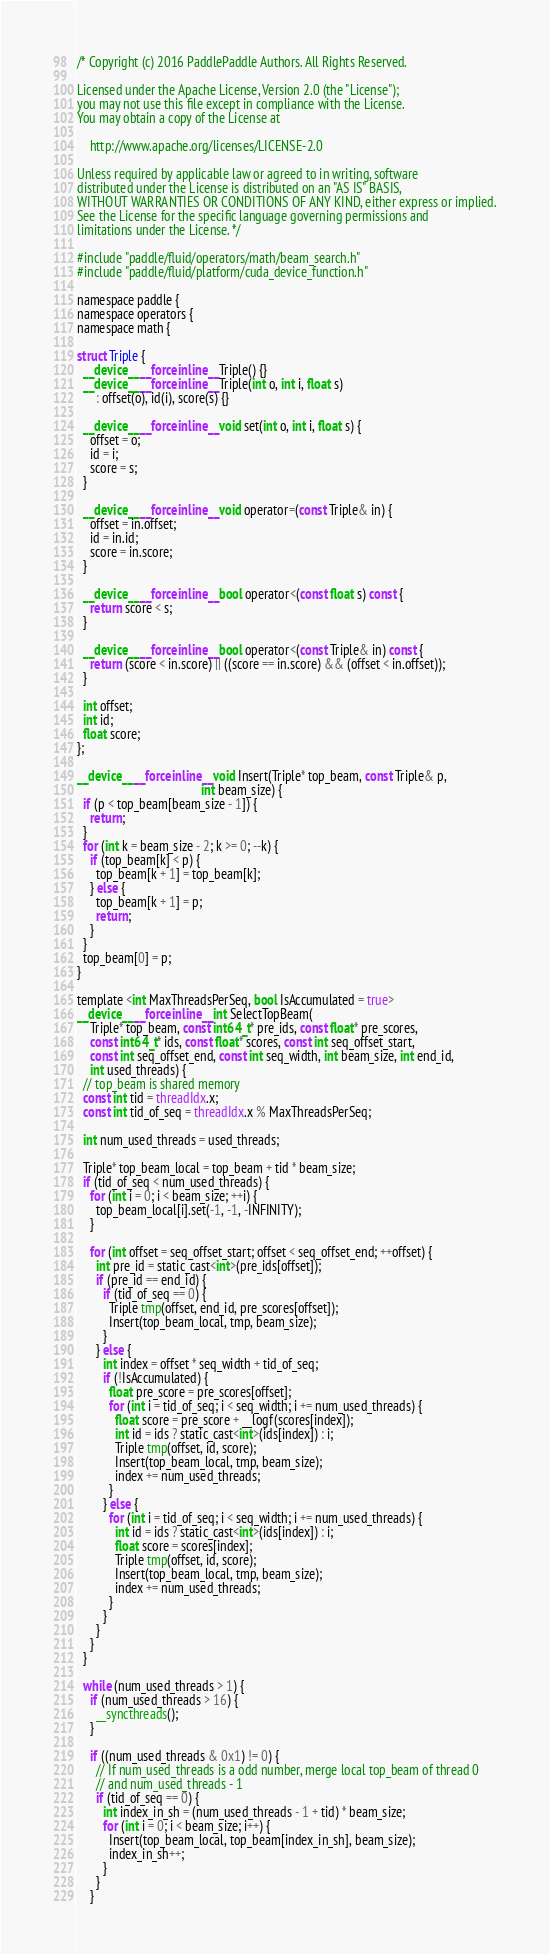<code> <loc_0><loc_0><loc_500><loc_500><_Cuda_>/* Copyright (c) 2016 PaddlePaddle Authors. All Rights Reserved.

Licensed under the Apache License, Version 2.0 (the "License");
you may not use this file except in compliance with the License.
You may obtain a copy of the License at

    http://www.apache.org/licenses/LICENSE-2.0

Unless required by applicable law or agreed to in writing, software
distributed under the License is distributed on an "AS IS" BASIS,
WITHOUT WARRANTIES OR CONDITIONS OF ANY KIND, either express or implied.
See the License for the specific language governing permissions and
limitations under the License. */

#include "paddle/fluid/operators/math/beam_search.h"
#include "paddle/fluid/platform/cuda_device_function.h"

namespace paddle {
namespace operators {
namespace math {

struct Triple {
  __device__ __forceinline__ Triple() {}
  __device__ __forceinline__ Triple(int o, int i, float s)
      : offset(o), id(i), score(s) {}

  __device__ __forceinline__ void set(int o, int i, float s) {
    offset = o;
    id = i;
    score = s;
  }

  __device__ __forceinline__ void operator=(const Triple& in) {
    offset = in.offset;
    id = in.id;
    score = in.score;
  }

  __device__ __forceinline__ bool operator<(const float s) const {
    return score < s;
  }

  __device__ __forceinline__ bool operator<(const Triple& in) const {
    return (score < in.score) || ((score == in.score) && (offset < in.offset));
  }

  int offset;
  int id;
  float score;
};

__device__ __forceinline__ void Insert(Triple* top_beam, const Triple& p,
                                       int beam_size) {
  if (p < top_beam[beam_size - 1]) {
    return;
  }
  for (int k = beam_size - 2; k >= 0; --k) {
    if (top_beam[k] < p) {
      top_beam[k + 1] = top_beam[k];
    } else {
      top_beam[k + 1] = p;
      return;
    }
  }
  top_beam[0] = p;
}

template <int MaxThreadsPerSeq, bool IsAccumulated = true>
__device__ __forceinline__ int SelectTopBeam(
    Triple* top_beam, const int64_t* pre_ids, const float* pre_scores,
    const int64_t* ids, const float* scores, const int seq_offset_start,
    const int seq_offset_end, const int seq_width, int beam_size, int end_id,
    int used_threads) {
  // top_beam is shared memory
  const int tid = threadIdx.x;
  const int tid_of_seq = threadIdx.x % MaxThreadsPerSeq;

  int num_used_threads = used_threads;

  Triple* top_beam_local = top_beam + tid * beam_size;
  if (tid_of_seq < num_used_threads) {
    for (int i = 0; i < beam_size; ++i) {
      top_beam_local[i].set(-1, -1, -INFINITY);
    }

    for (int offset = seq_offset_start; offset < seq_offset_end; ++offset) {
      int pre_id = static_cast<int>(pre_ids[offset]);
      if (pre_id == end_id) {
        if (tid_of_seq == 0) {
          Triple tmp(offset, end_id, pre_scores[offset]);
          Insert(top_beam_local, tmp, beam_size);
        }
      } else {
        int index = offset * seq_width + tid_of_seq;
        if (!IsAccumulated) {
          float pre_score = pre_scores[offset];
          for (int i = tid_of_seq; i < seq_width; i += num_used_threads) {
            float score = pre_score + __logf(scores[index]);
            int id = ids ? static_cast<int>(ids[index]) : i;
            Triple tmp(offset, id, score);
            Insert(top_beam_local, tmp, beam_size);
            index += num_used_threads;
          }
        } else {
          for (int i = tid_of_seq; i < seq_width; i += num_used_threads) {
            int id = ids ? static_cast<int>(ids[index]) : i;
            float score = scores[index];
            Triple tmp(offset, id, score);
            Insert(top_beam_local, tmp, beam_size);
            index += num_used_threads;
          }
        }
      }
    }
  }

  while (num_used_threads > 1) {
    if (num_used_threads > 16) {
      __syncthreads();
    }

    if ((num_used_threads & 0x1) != 0) {
      // If num_used_threads is a odd number, merge local top_beam of thread 0
      // and num_used_threads - 1
      if (tid_of_seq == 0) {
        int index_in_sh = (num_used_threads - 1 + tid) * beam_size;
        for (int i = 0; i < beam_size; i++) {
          Insert(top_beam_local, top_beam[index_in_sh], beam_size);
          index_in_sh++;
        }
      }
    }
</code> 